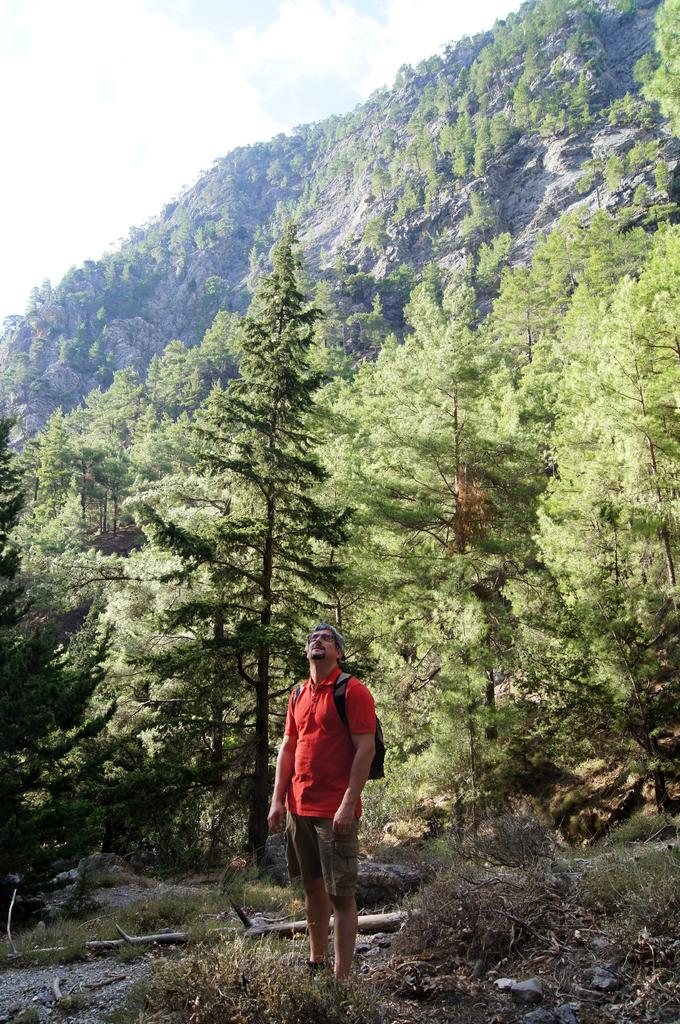What is the main subject of the image? There is a person standing in the image. What type of natural environment is depicted in the image? There are many trees and a mountain in the image. What is the condition of the sky in the image? The sky is clear in the image. Can you hear the voice of the person in the image? There is no indication of sound or voice in the image, as it is a still photograph. Is the person in the image wearing a winter coat? The provided facts do not mention any clothing or weather-related details, so it cannot be determined if the person is wearing a winter coat. 